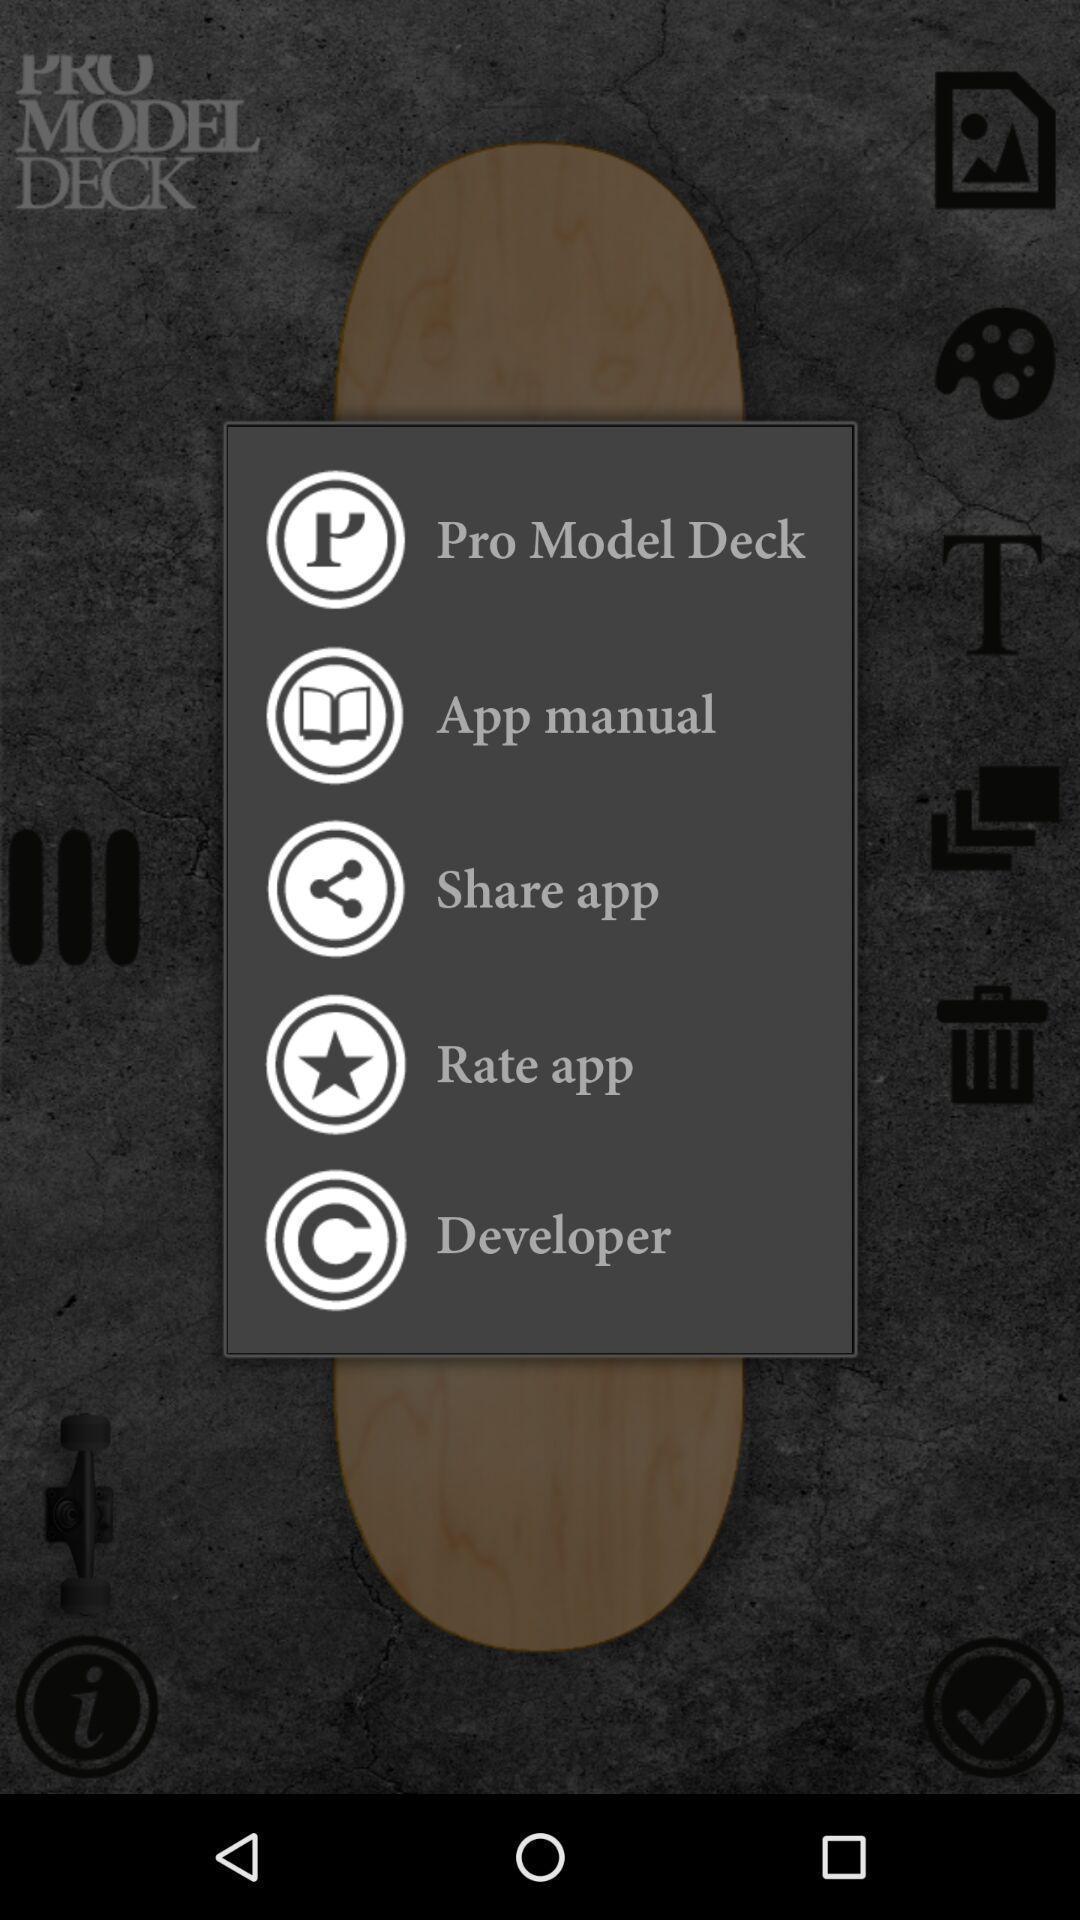Describe this image in words. Pop-up displaying options for skateboarding app. 